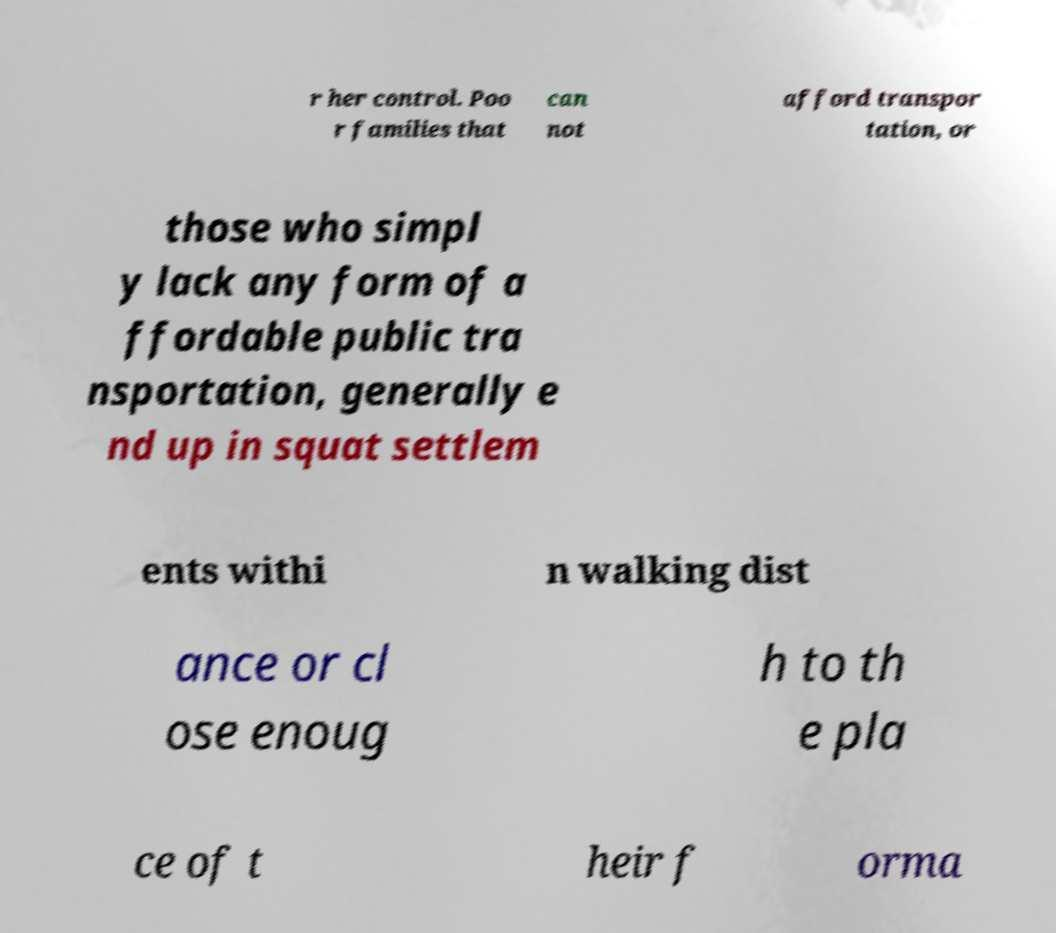Could you extract and type out the text from this image? r her control. Poo r families that can not afford transpor tation, or those who simpl y lack any form of a ffordable public tra nsportation, generally e nd up in squat settlem ents withi n walking dist ance or cl ose enoug h to th e pla ce of t heir f orma 